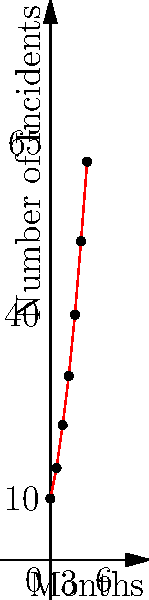The line graph shows the number of cybersecurity incidents reported over a 6-month period for a large e-commerce company. Calculate the average rate of change in the number of incidents per month between the 3rd and 6th month. To calculate the average rate of change between two points, we use the formula:

$$ \text{Rate of Change} = \frac{\text{Change in y}}{\text{Change in x}} $$

1. Identify the points:
   - At 3 months: (3, 30)
   - At 6 months: (6, 65)

2. Calculate the change in y (number of incidents):
   $\Delta y = 65 - 30 = 35$

3. Calculate the change in x (months):
   $\Delta x = 6 - 3 = 3$

4. Apply the formula:
   $$ \text{Rate of Change} = \frac{35}{3} \approx 11.67 $$

Therefore, the average rate of change in the number of incidents per month between the 3rd and 6th month is approximately 11.67 incidents per month.
Answer: 11.67 incidents/month 